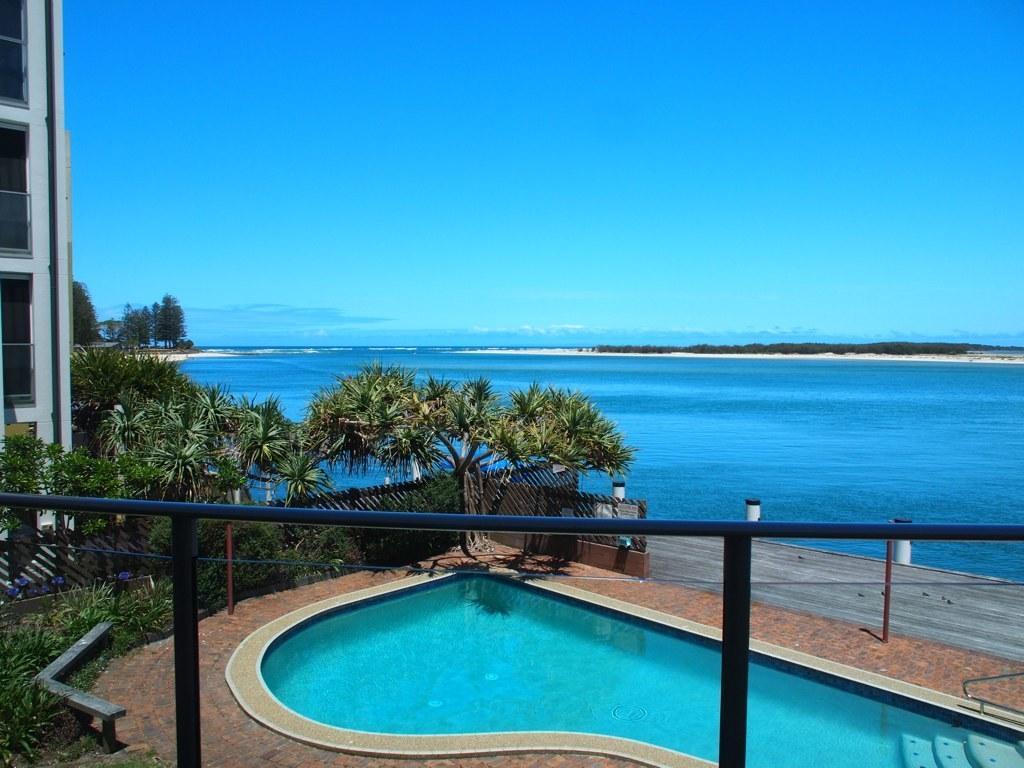Please provide a concise description of this image. In this picture we can see swimming pool at the bottom, in the background there is water, we can see trees and a building on the left side, at the left bottom there are some plants, we can see the sky at the top of the picture. 